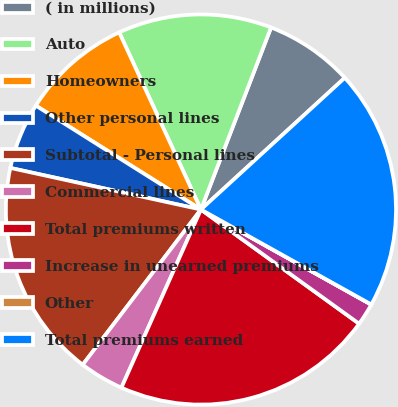Convert chart to OTSL. <chart><loc_0><loc_0><loc_500><loc_500><pie_chart><fcel>( in millions)<fcel>Auto<fcel>Homeowners<fcel>Other personal lines<fcel>Subtotal - Personal lines<fcel>Commercial lines<fcel>Total premiums written<fcel>Increase in unearned premiums<fcel>Other<fcel>Total premiums earned<nl><fcel>7.35%<fcel>12.73%<fcel>9.18%<fcel>5.52%<fcel>18.06%<fcel>3.68%<fcel>21.73%<fcel>1.85%<fcel>0.01%<fcel>19.89%<nl></chart> 